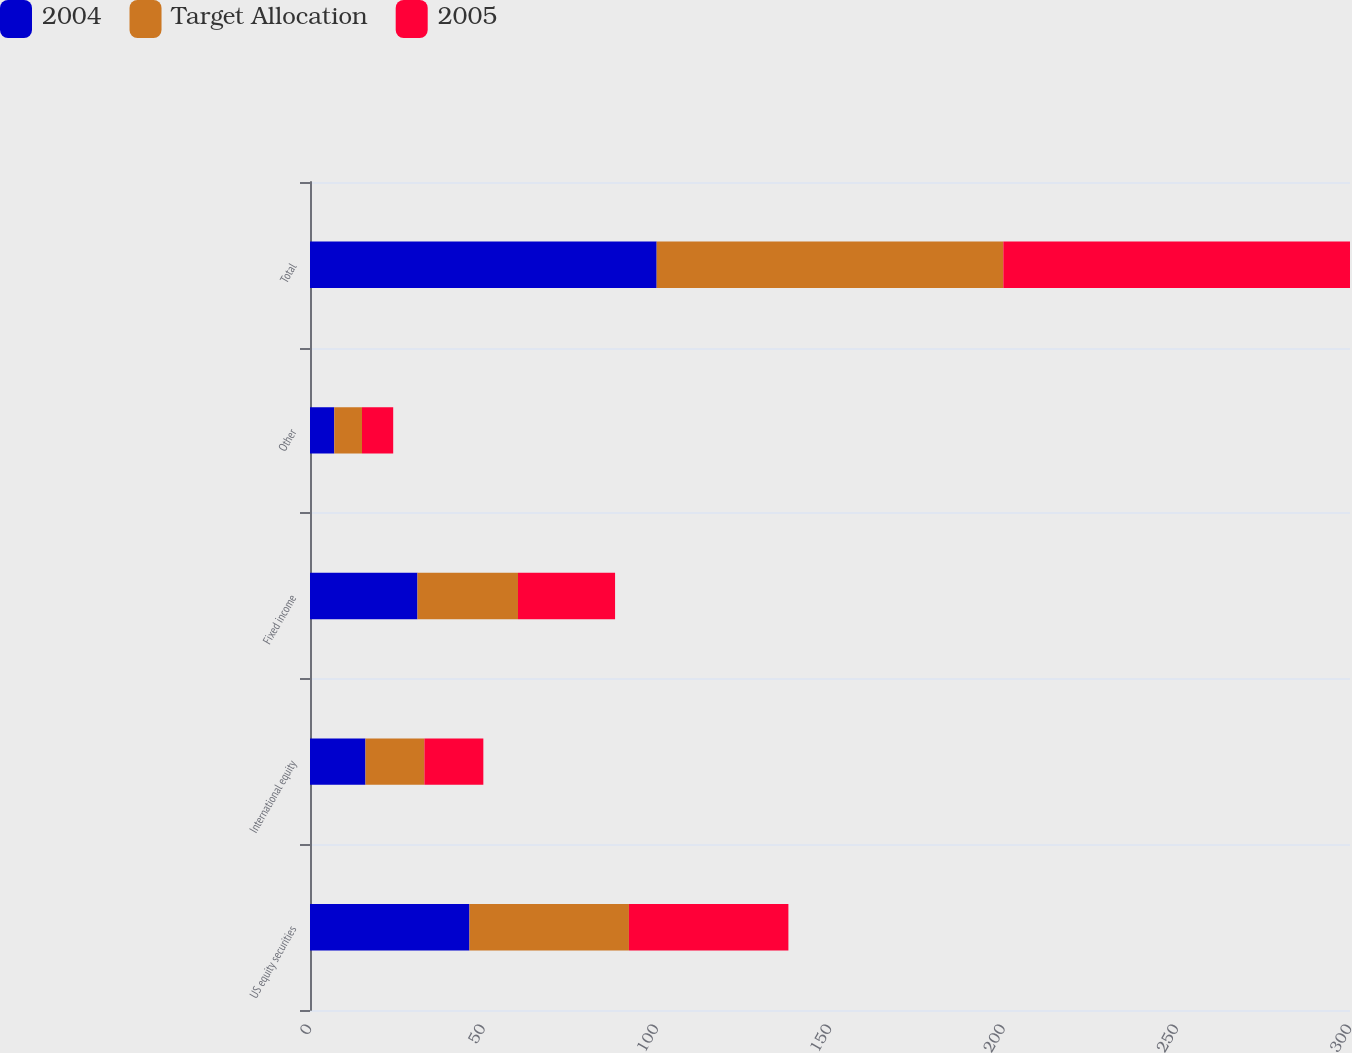Convert chart. <chart><loc_0><loc_0><loc_500><loc_500><stacked_bar_chart><ecel><fcel>US equity securities<fcel>International equity<fcel>Fixed income<fcel>Other<fcel>Total<nl><fcel>2004<fcel>46<fcel>16<fcel>31<fcel>7<fcel>100<nl><fcel>Target Allocation<fcel>46<fcel>17<fcel>29<fcel>8<fcel>100<nl><fcel>2005<fcel>46<fcel>17<fcel>28<fcel>9<fcel>100<nl></chart> 